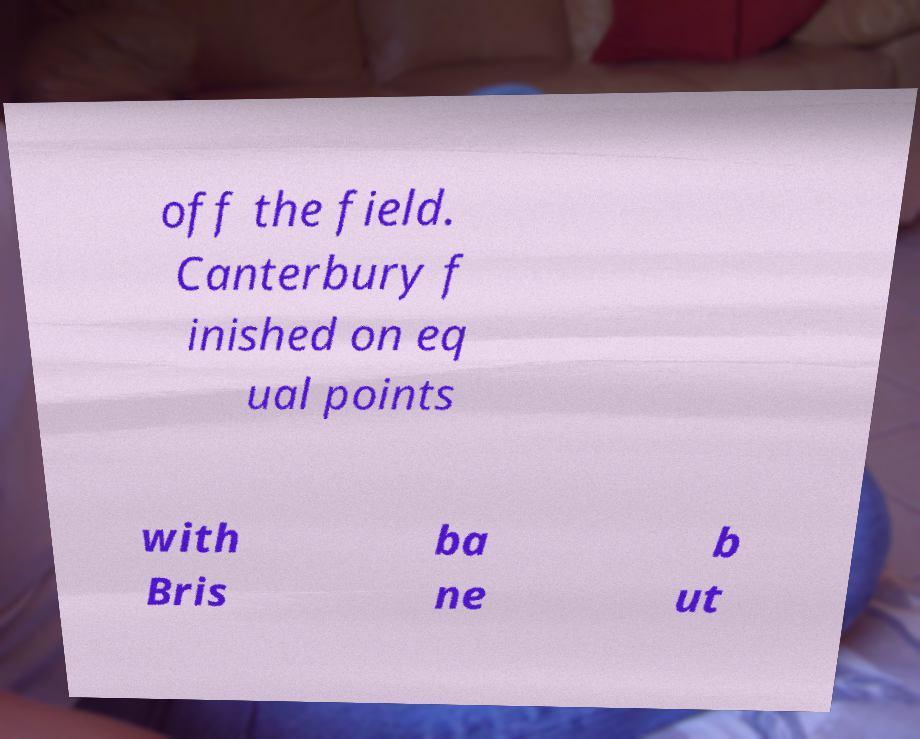What messages or text are displayed in this image? I need them in a readable, typed format. off the field. Canterbury f inished on eq ual points with Bris ba ne b ut 